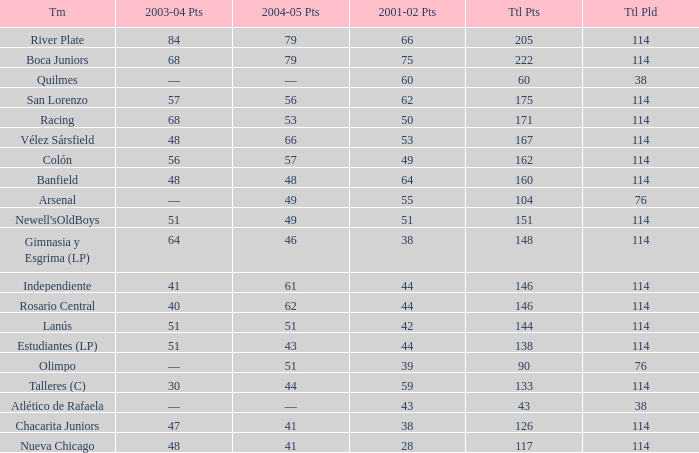Which Team has a Total Pld smaller than 114, and a 2004–05 Pts of 49? Arsenal. 